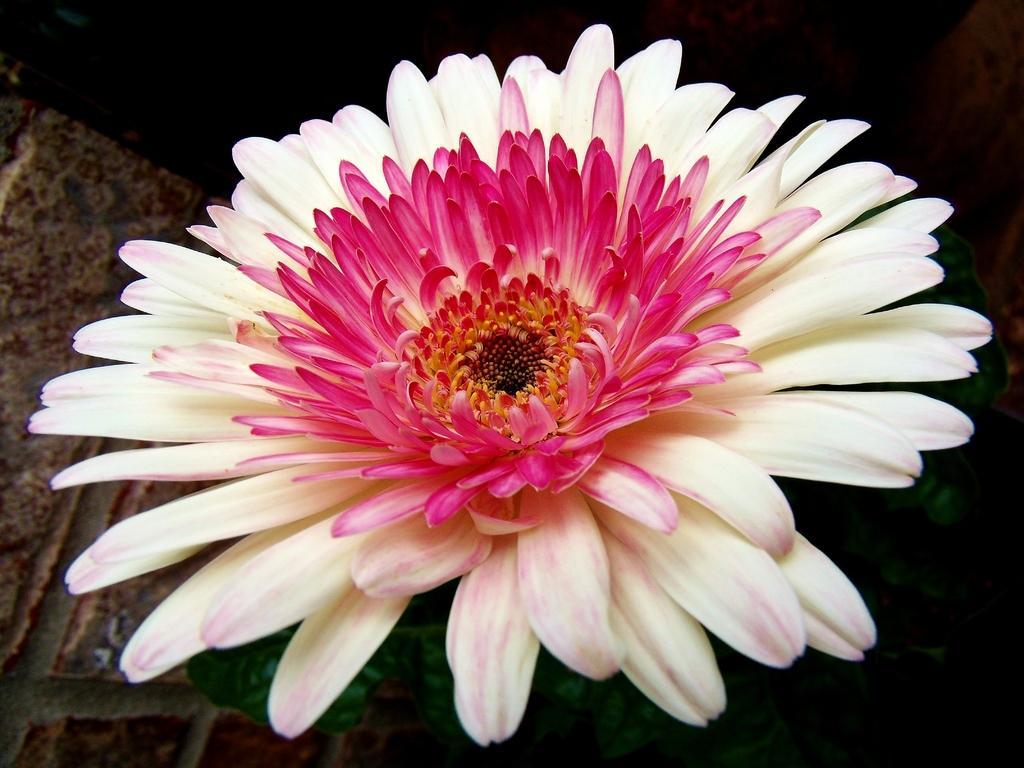Please provide a concise description of this image. There is a white and pink color flower with leaves. 